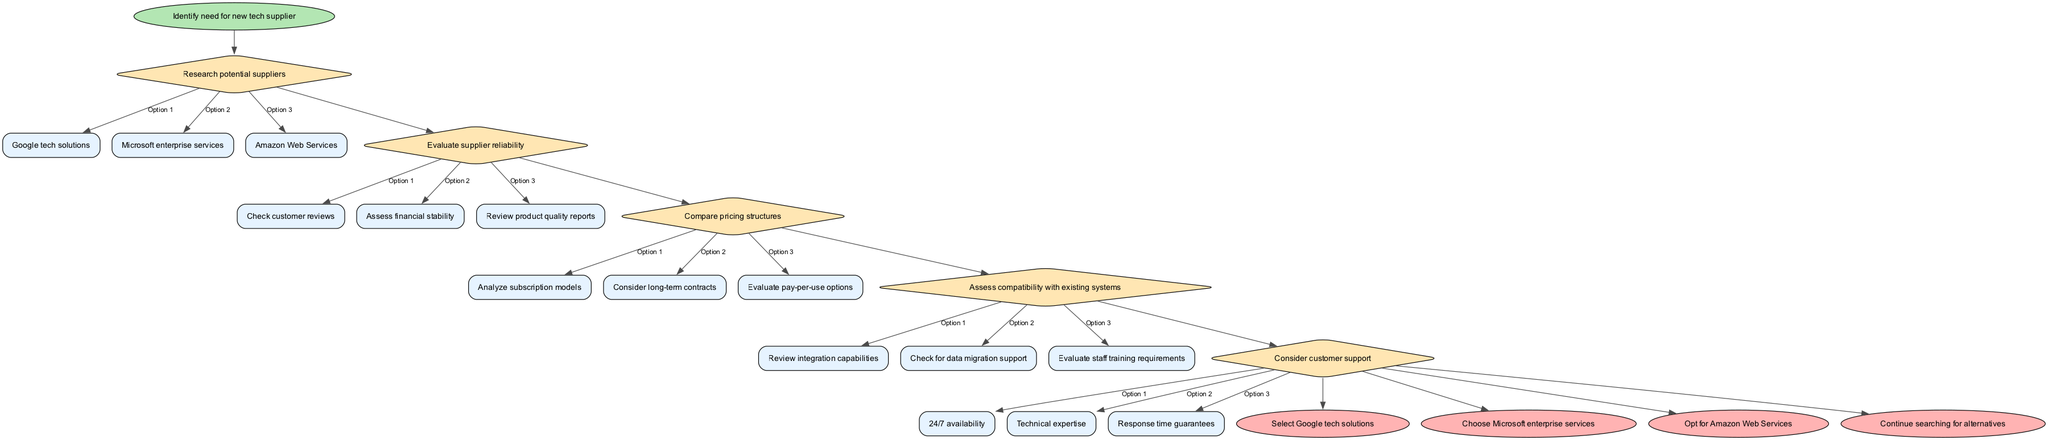What is the starting point of the flowchart? The starting point is indicated as the first node in the flowchart labeled "Identify need for new tech supplier."
Answer: Identify need for new tech supplier How many decision nodes are present in the diagram? By counting the nodes designated as diamonds, we find that there are five decision nodes in total.
Answer: 5 What are the options available after evaluating supplier reliability? The options listed under evaluating supplier reliability are "Check customer reviews," "Assess financial stability," and "Review product quality reports."
Answer: Check customer reviews, Assess financial stability, Review product quality reports Which tech supplier option leads to a decision point? The options "Select Google tech solutions," "Choose Microsoft enterprise services," and "Opt for Amazon Web Services" lead to the decision point at the end nodes.
Answer: Select Google tech solutions, Choose Microsoft enterprise services, Opt for Amazon Web Services What is the last decision node in the flowchart? The last decision node, which is the fifth one, is about considering customer support.
Answer: Consider customer support What is the relationship between "Compare pricing structures" and "Assess compatibility with existing systems"? "Assess compatibility with existing systems" follows after "Compare pricing structures," indicating a sequential decision-making process where both are part of the decision nodes.
Answer: Sequential relationship If the decision process reaches the end nodes, what options remain? The potential end nodes are "Select Google tech solutions," "Choose Microsoft enterprise services," "Opt for Amazon Web Services," or "Continue searching for alternatives."
Answer: Select Google tech solutions, Choose Microsoft enterprise services, Opt for Amazon Web Services, Continue searching for alternatives What are the three options considered under pricing structures? The options include "Analyze subscription models," "Consider long-term contracts," and "Evaluate pay-per-use options."
Answer: Analyze subscription models, Consider long-term contracts, Evaluate pay-per-use options What type of structure is used for the nodes representing decision points in the diagram? The decision points in the flowchart are represented using a diamond shape.
Answer: Diamond shape 